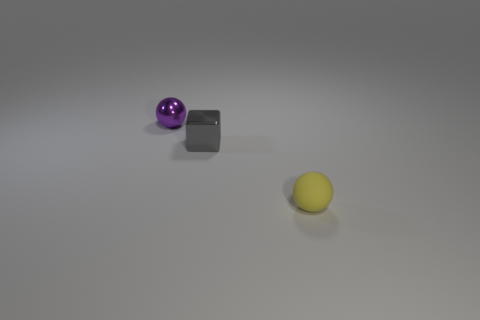Is there anything distinguishable in the background? The background is quite plain and unadorned, featuring a solid horizon line that distinguishes the floor from the wall. The floor has a subtle gradient, slightly darker near the bottom of the image and becoming lighter as it stretches away from the viewer. No additional objects or features are present, which creates a neutral and nondescript setting for the objects in focus. 